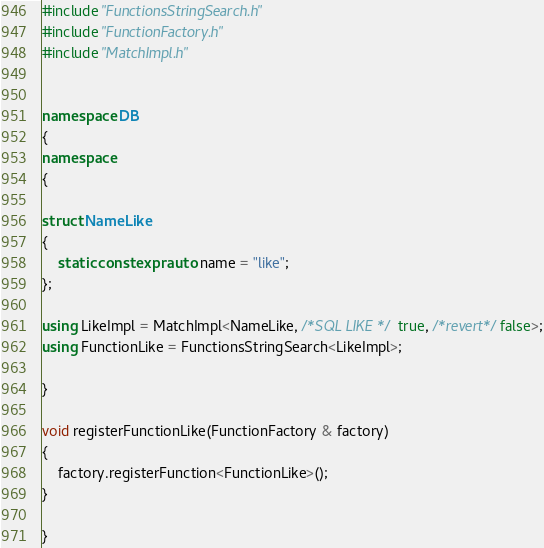<code> <loc_0><loc_0><loc_500><loc_500><_C++_>#include "FunctionsStringSearch.h"
#include "FunctionFactory.h"
#include "MatchImpl.h"


namespace DB
{
namespace
{

struct NameLike
{
    static constexpr auto name = "like";
};

using LikeImpl = MatchImpl<NameLike, /*SQL LIKE */ true, /*revert*/false>;
using FunctionLike = FunctionsStringSearch<LikeImpl>;

}

void registerFunctionLike(FunctionFactory & factory)
{
    factory.registerFunction<FunctionLike>();
}

}
</code> 